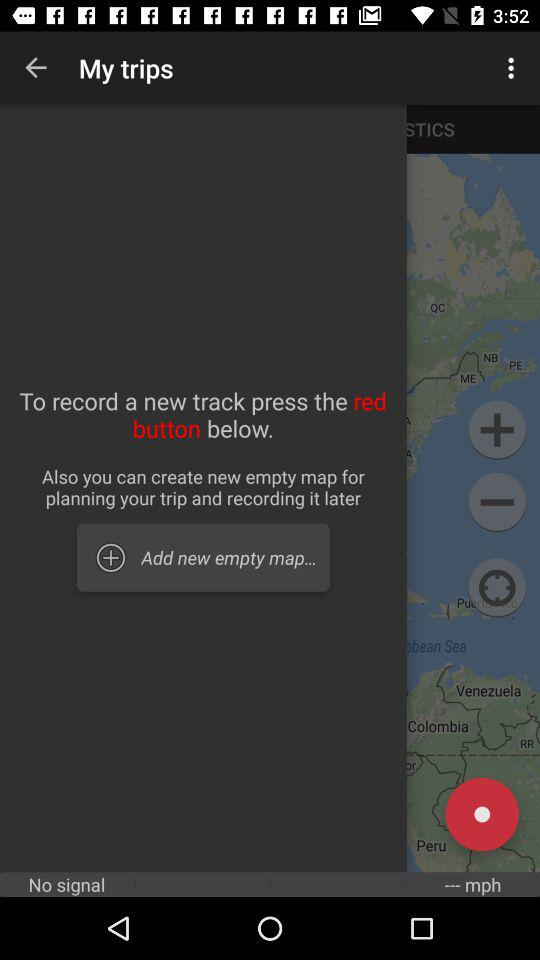How to record my new track? To record your new track, press the "red button" below. 